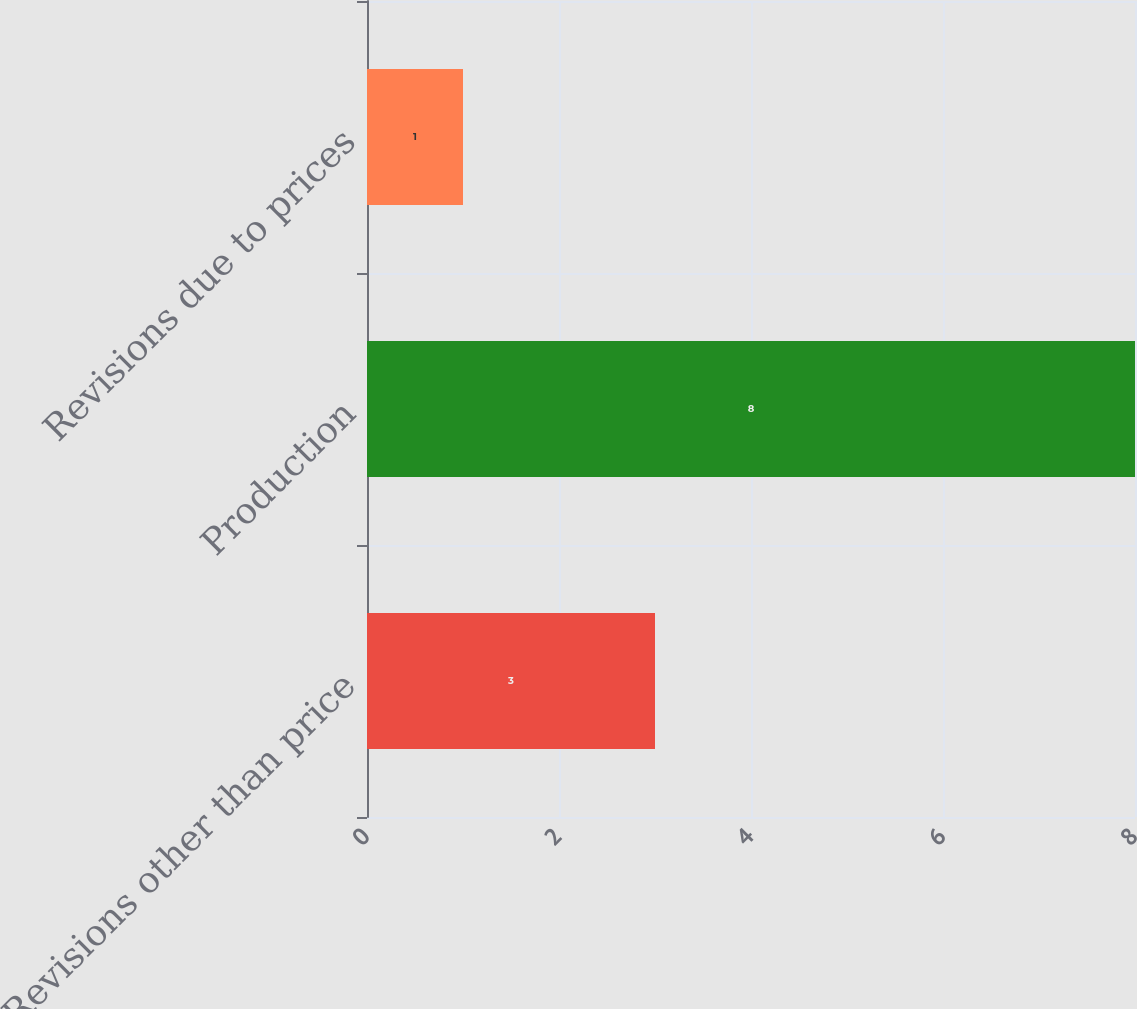Convert chart to OTSL. <chart><loc_0><loc_0><loc_500><loc_500><bar_chart><fcel>Revisions other than price<fcel>Production<fcel>Revisions due to prices<nl><fcel>3<fcel>8<fcel>1<nl></chart> 